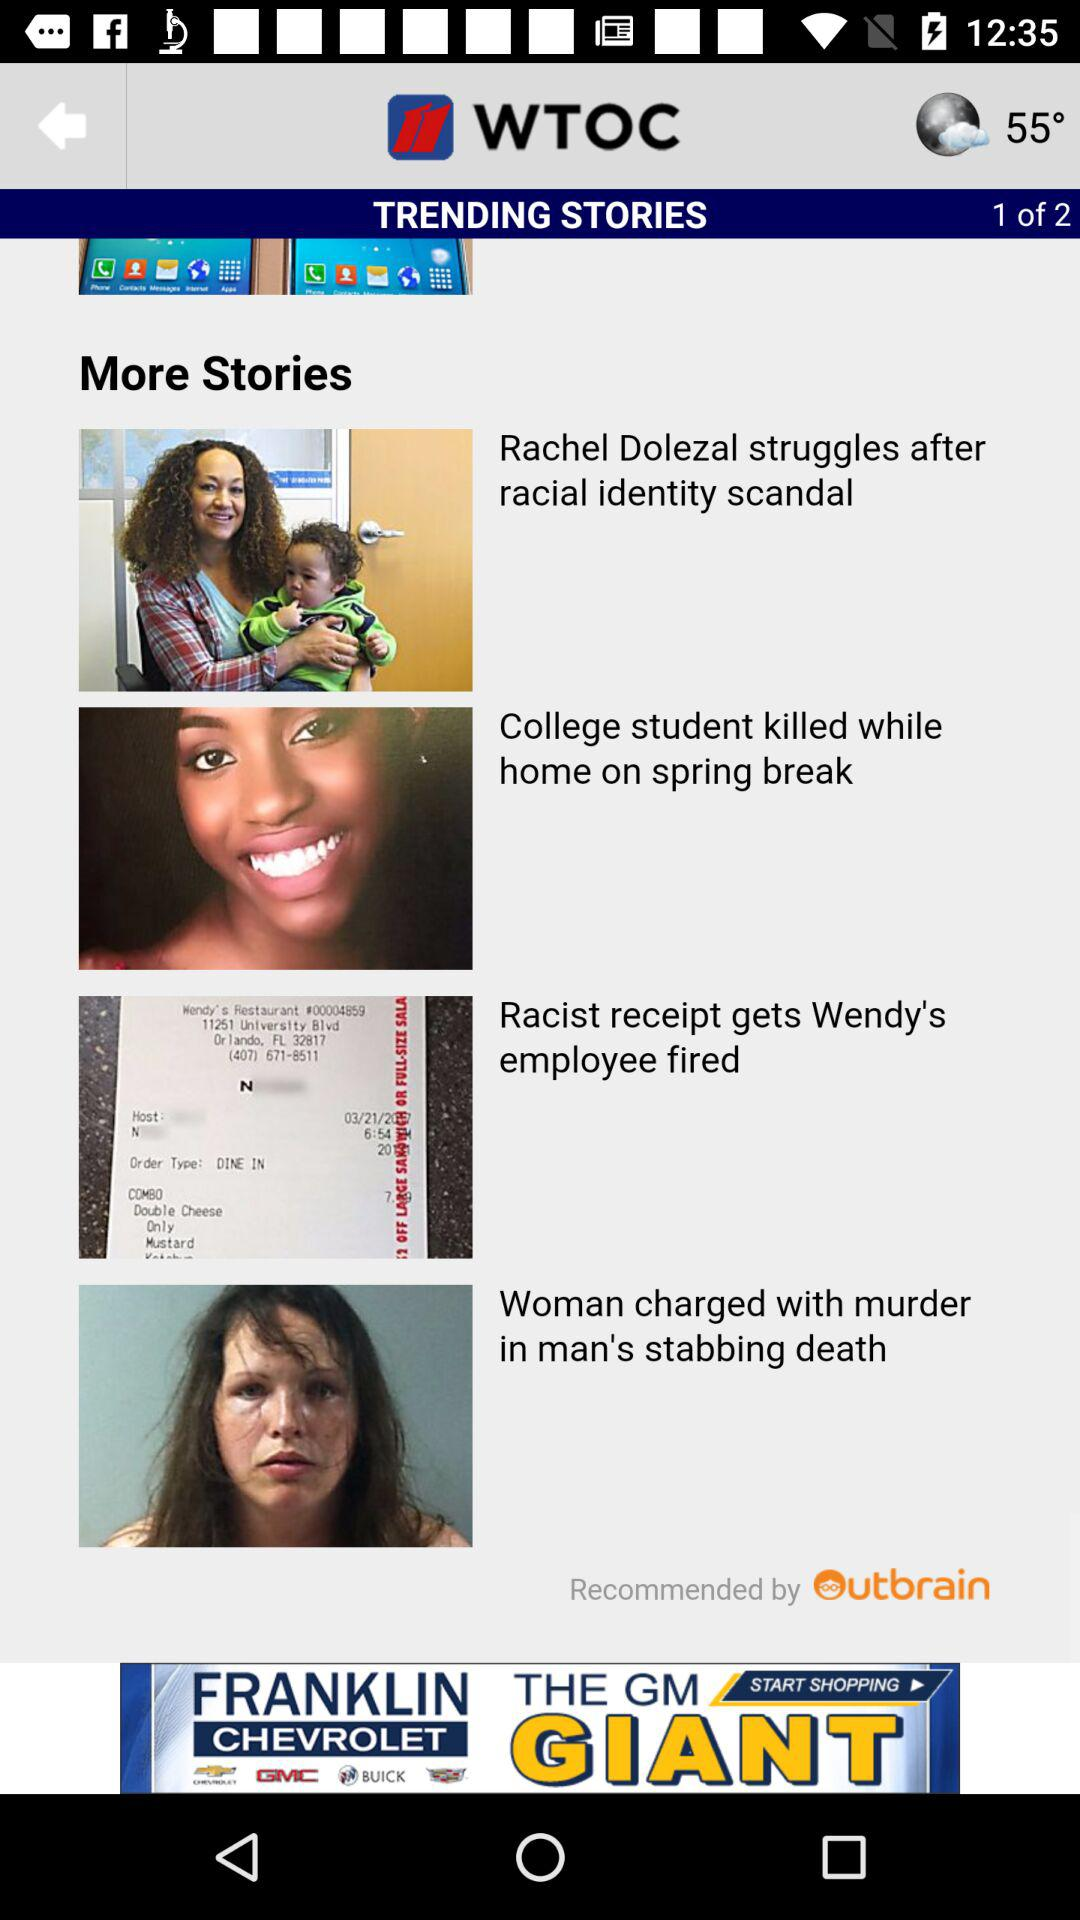What is the temperature shown on the screen? The temperature shown on the screen is 55°. 